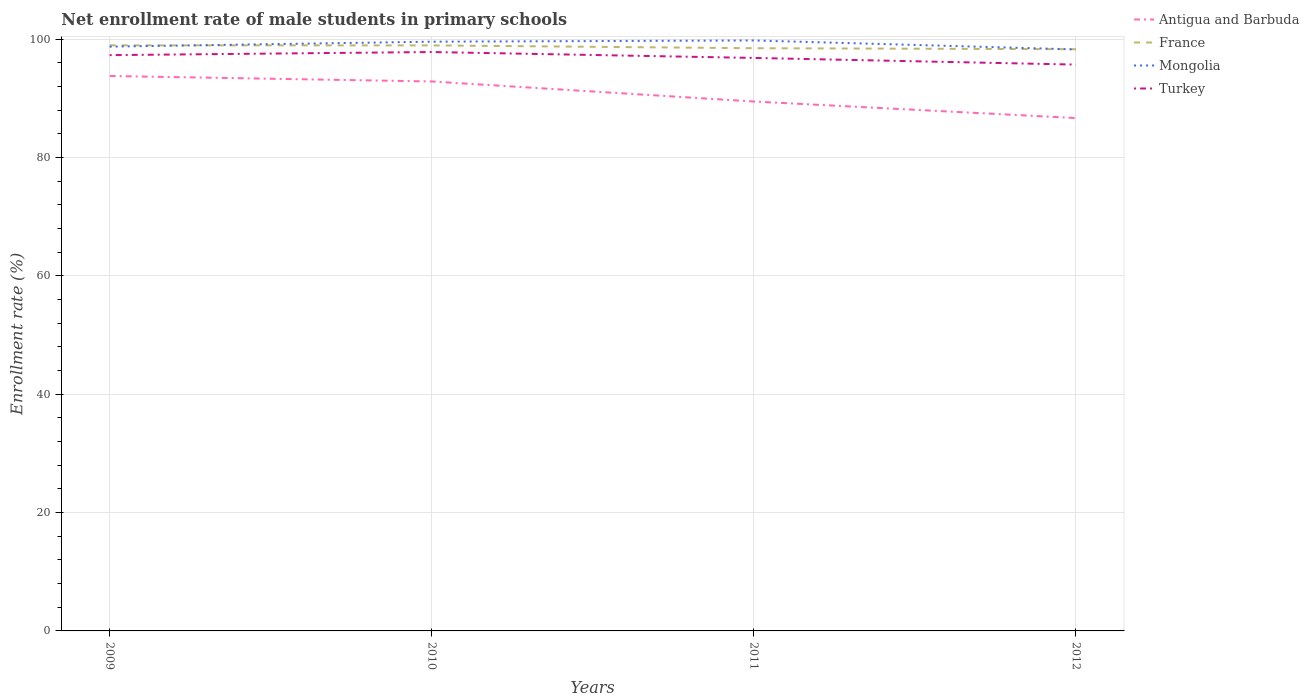How many different coloured lines are there?
Offer a very short reply. 4. Is the number of lines equal to the number of legend labels?
Give a very brief answer. Yes. Across all years, what is the maximum net enrollment rate of male students in primary schools in Mongolia?
Offer a terse response. 98.28. What is the total net enrollment rate of male students in primary schools in France in the graph?
Keep it short and to the point. 0.64. What is the difference between the highest and the second highest net enrollment rate of male students in primary schools in Antigua and Barbuda?
Give a very brief answer. 7.11. What is the difference between the highest and the lowest net enrollment rate of male students in primary schools in Mongolia?
Offer a terse response. 2. Is the net enrollment rate of male students in primary schools in Antigua and Barbuda strictly greater than the net enrollment rate of male students in primary schools in France over the years?
Your response must be concise. Yes. How many lines are there?
Your answer should be very brief. 4. How many years are there in the graph?
Give a very brief answer. 4. Does the graph contain grids?
Your answer should be very brief. Yes. Where does the legend appear in the graph?
Ensure brevity in your answer.  Top right. How are the legend labels stacked?
Offer a terse response. Vertical. What is the title of the graph?
Provide a short and direct response. Net enrollment rate of male students in primary schools. Does "Curacao" appear as one of the legend labels in the graph?
Your answer should be very brief. No. What is the label or title of the X-axis?
Your answer should be compact. Years. What is the label or title of the Y-axis?
Give a very brief answer. Enrollment rate (%). What is the Enrollment rate (%) in Antigua and Barbuda in 2009?
Give a very brief answer. 93.79. What is the Enrollment rate (%) in France in 2009?
Ensure brevity in your answer.  98.97. What is the Enrollment rate (%) of Mongolia in 2009?
Keep it short and to the point. 98.75. What is the Enrollment rate (%) in Turkey in 2009?
Give a very brief answer. 97.31. What is the Enrollment rate (%) of Antigua and Barbuda in 2010?
Offer a very short reply. 92.86. What is the Enrollment rate (%) of France in 2010?
Your answer should be compact. 98.96. What is the Enrollment rate (%) in Mongolia in 2010?
Your response must be concise. 99.59. What is the Enrollment rate (%) of Turkey in 2010?
Provide a short and direct response. 97.84. What is the Enrollment rate (%) in Antigua and Barbuda in 2011?
Offer a very short reply. 89.48. What is the Enrollment rate (%) in France in 2011?
Provide a short and direct response. 98.48. What is the Enrollment rate (%) in Mongolia in 2011?
Keep it short and to the point. 99.79. What is the Enrollment rate (%) in Turkey in 2011?
Offer a terse response. 96.84. What is the Enrollment rate (%) in Antigua and Barbuda in 2012?
Your response must be concise. 86.68. What is the Enrollment rate (%) in France in 2012?
Offer a terse response. 98.31. What is the Enrollment rate (%) in Mongolia in 2012?
Your response must be concise. 98.28. What is the Enrollment rate (%) in Turkey in 2012?
Your response must be concise. 95.71. Across all years, what is the maximum Enrollment rate (%) in Antigua and Barbuda?
Ensure brevity in your answer.  93.79. Across all years, what is the maximum Enrollment rate (%) in France?
Provide a succinct answer. 98.97. Across all years, what is the maximum Enrollment rate (%) in Mongolia?
Your answer should be compact. 99.79. Across all years, what is the maximum Enrollment rate (%) of Turkey?
Keep it short and to the point. 97.84. Across all years, what is the minimum Enrollment rate (%) of Antigua and Barbuda?
Your answer should be very brief. 86.68. Across all years, what is the minimum Enrollment rate (%) in France?
Offer a terse response. 98.31. Across all years, what is the minimum Enrollment rate (%) in Mongolia?
Your response must be concise. 98.28. Across all years, what is the minimum Enrollment rate (%) of Turkey?
Give a very brief answer. 95.71. What is the total Enrollment rate (%) in Antigua and Barbuda in the graph?
Provide a short and direct response. 362.81. What is the total Enrollment rate (%) in France in the graph?
Offer a very short reply. 394.72. What is the total Enrollment rate (%) in Mongolia in the graph?
Provide a short and direct response. 396.41. What is the total Enrollment rate (%) of Turkey in the graph?
Your answer should be compact. 387.71. What is the difference between the Enrollment rate (%) of Antigua and Barbuda in 2009 and that in 2010?
Provide a succinct answer. 0.92. What is the difference between the Enrollment rate (%) in France in 2009 and that in 2010?
Make the answer very short. 0.01. What is the difference between the Enrollment rate (%) of Mongolia in 2009 and that in 2010?
Ensure brevity in your answer.  -0.84. What is the difference between the Enrollment rate (%) of Turkey in 2009 and that in 2010?
Your response must be concise. -0.53. What is the difference between the Enrollment rate (%) of Antigua and Barbuda in 2009 and that in 2011?
Give a very brief answer. 4.31. What is the difference between the Enrollment rate (%) of France in 2009 and that in 2011?
Ensure brevity in your answer.  0.48. What is the difference between the Enrollment rate (%) in Mongolia in 2009 and that in 2011?
Provide a short and direct response. -1.04. What is the difference between the Enrollment rate (%) in Turkey in 2009 and that in 2011?
Your answer should be very brief. 0.47. What is the difference between the Enrollment rate (%) in Antigua and Barbuda in 2009 and that in 2012?
Your response must be concise. 7.11. What is the difference between the Enrollment rate (%) in France in 2009 and that in 2012?
Make the answer very short. 0.65. What is the difference between the Enrollment rate (%) in Mongolia in 2009 and that in 2012?
Your response must be concise. 0.47. What is the difference between the Enrollment rate (%) in Turkey in 2009 and that in 2012?
Ensure brevity in your answer.  1.6. What is the difference between the Enrollment rate (%) in Antigua and Barbuda in 2010 and that in 2011?
Your answer should be very brief. 3.39. What is the difference between the Enrollment rate (%) of France in 2010 and that in 2011?
Your response must be concise. 0.47. What is the difference between the Enrollment rate (%) in Mongolia in 2010 and that in 2011?
Offer a very short reply. -0.21. What is the difference between the Enrollment rate (%) in Turkey in 2010 and that in 2011?
Offer a very short reply. 1. What is the difference between the Enrollment rate (%) of Antigua and Barbuda in 2010 and that in 2012?
Provide a short and direct response. 6.18. What is the difference between the Enrollment rate (%) in France in 2010 and that in 2012?
Ensure brevity in your answer.  0.64. What is the difference between the Enrollment rate (%) of Mongolia in 2010 and that in 2012?
Keep it short and to the point. 1.31. What is the difference between the Enrollment rate (%) in Turkey in 2010 and that in 2012?
Offer a terse response. 2.12. What is the difference between the Enrollment rate (%) in Antigua and Barbuda in 2011 and that in 2012?
Offer a terse response. 2.8. What is the difference between the Enrollment rate (%) of France in 2011 and that in 2012?
Provide a succinct answer. 0.17. What is the difference between the Enrollment rate (%) in Mongolia in 2011 and that in 2012?
Give a very brief answer. 1.51. What is the difference between the Enrollment rate (%) in Turkey in 2011 and that in 2012?
Provide a short and direct response. 1.13. What is the difference between the Enrollment rate (%) in Antigua and Barbuda in 2009 and the Enrollment rate (%) in France in 2010?
Offer a very short reply. -5.17. What is the difference between the Enrollment rate (%) in Antigua and Barbuda in 2009 and the Enrollment rate (%) in Mongolia in 2010?
Provide a short and direct response. -5.8. What is the difference between the Enrollment rate (%) in Antigua and Barbuda in 2009 and the Enrollment rate (%) in Turkey in 2010?
Your answer should be compact. -4.05. What is the difference between the Enrollment rate (%) in France in 2009 and the Enrollment rate (%) in Mongolia in 2010?
Provide a succinct answer. -0.62. What is the difference between the Enrollment rate (%) of France in 2009 and the Enrollment rate (%) of Turkey in 2010?
Your answer should be very brief. 1.13. What is the difference between the Enrollment rate (%) of Mongolia in 2009 and the Enrollment rate (%) of Turkey in 2010?
Your answer should be very brief. 0.91. What is the difference between the Enrollment rate (%) in Antigua and Barbuda in 2009 and the Enrollment rate (%) in France in 2011?
Your answer should be compact. -4.7. What is the difference between the Enrollment rate (%) in Antigua and Barbuda in 2009 and the Enrollment rate (%) in Mongolia in 2011?
Keep it short and to the point. -6.01. What is the difference between the Enrollment rate (%) of Antigua and Barbuda in 2009 and the Enrollment rate (%) of Turkey in 2011?
Offer a very short reply. -3.05. What is the difference between the Enrollment rate (%) in France in 2009 and the Enrollment rate (%) in Mongolia in 2011?
Keep it short and to the point. -0.83. What is the difference between the Enrollment rate (%) of France in 2009 and the Enrollment rate (%) of Turkey in 2011?
Your response must be concise. 2.13. What is the difference between the Enrollment rate (%) of Mongolia in 2009 and the Enrollment rate (%) of Turkey in 2011?
Provide a succinct answer. 1.91. What is the difference between the Enrollment rate (%) in Antigua and Barbuda in 2009 and the Enrollment rate (%) in France in 2012?
Make the answer very short. -4.53. What is the difference between the Enrollment rate (%) of Antigua and Barbuda in 2009 and the Enrollment rate (%) of Mongolia in 2012?
Offer a terse response. -4.49. What is the difference between the Enrollment rate (%) in Antigua and Barbuda in 2009 and the Enrollment rate (%) in Turkey in 2012?
Ensure brevity in your answer.  -1.93. What is the difference between the Enrollment rate (%) of France in 2009 and the Enrollment rate (%) of Mongolia in 2012?
Offer a terse response. 0.69. What is the difference between the Enrollment rate (%) in France in 2009 and the Enrollment rate (%) in Turkey in 2012?
Offer a very short reply. 3.25. What is the difference between the Enrollment rate (%) in Mongolia in 2009 and the Enrollment rate (%) in Turkey in 2012?
Your answer should be compact. 3.04. What is the difference between the Enrollment rate (%) of Antigua and Barbuda in 2010 and the Enrollment rate (%) of France in 2011?
Ensure brevity in your answer.  -5.62. What is the difference between the Enrollment rate (%) in Antigua and Barbuda in 2010 and the Enrollment rate (%) in Mongolia in 2011?
Offer a terse response. -6.93. What is the difference between the Enrollment rate (%) of Antigua and Barbuda in 2010 and the Enrollment rate (%) of Turkey in 2011?
Ensure brevity in your answer.  -3.98. What is the difference between the Enrollment rate (%) in France in 2010 and the Enrollment rate (%) in Mongolia in 2011?
Offer a very short reply. -0.84. What is the difference between the Enrollment rate (%) of France in 2010 and the Enrollment rate (%) of Turkey in 2011?
Keep it short and to the point. 2.12. What is the difference between the Enrollment rate (%) in Mongolia in 2010 and the Enrollment rate (%) in Turkey in 2011?
Your response must be concise. 2.75. What is the difference between the Enrollment rate (%) of Antigua and Barbuda in 2010 and the Enrollment rate (%) of France in 2012?
Provide a succinct answer. -5.45. What is the difference between the Enrollment rate (%) in Antigua and Barbuda in 2010 and the Enrollment rate (%) in Mongolia in 2012?
Ensure brevity in your answer.  -5.42. What is the difference between the Enrollment rate (%) in Antigua and Barbuda in 2010 and the Enrollment rate (%) in Turkey in 2012?
Provide a succinct answer. -2.85. What is the difference between the Enrollment rate (%) in France in 2010 and the Enrollment rate (%) in Mongolia in 2012?
Give a very brief answer. 0.68. What is the difference between the Enrollment rate (%) in France in 2010 and the Enrollment rate (%) in Turkey in 2012?
Offer a terse response. 3.24. What is the difference between the Enrollment rate (%) in Mongolia in 2010 and the Enrollment rate (%) in Turkey in 2012?
Your answer should be compact. 3.87. What is the difference between the Enrollment rate (%) of Antigua and Barbuda in 2011 and the Enrollment rate (%) of France in 2012?
Give a very brief answer. -8.84. What is the difference between the Enrollment rate (%) of Antigua and Barbuda in 2011 and the Enrollment rate (%) of Mongolia in 2012?
Your answer should be compact. -8.8. What is the difference between the Enrollment rate (%) of Antigua and Barbuda in 2011 and the Enrollment rate (%) of Turkey in 2012?
Offer a terse response. -6.24. What is the difference between the Enrollment rate (%) of France in 2011 and the Enrollment rate (%) of Mongolia in 2012?
Make the answer very short. 0.2. What is the difference between the Enrollment rate (%) in France in 2011 and the Enrollment rate (%) in Turkey in 2012?
Provide a short and direct response. 2.77. What is the difference between the Enrollment rate (%) in Mongolia in 2011 and the Enrollment rate (%) in Turkey in 2012?
Offer a terse response. 4.08. What is the average Enrollment rate (%) in Antigua and Barbuda per year?
Offer a very short reply. 90.7. What is the average Enrollment rate (%) of France per year?
Provide a succinct answer. 98.68. What is the average Enrollment rate (%) of Mongolia per year?
Give a very brief answer. 99.1. What is the average Enrollment rate (%) in Turkey per year?
Your response must be concise. 96.93. In the year 2009, what is the difference between the Enrollment rate (%) in Antigua and Barbuda and Enrollment rate (%) in France?
Your answer should be very brief. -5.18. In the year 2009, what is the difference between the Enrollment rate (%) in Antigua and Barbuda and Enrollment rate (%) in Mongolia?
Offer a terse response. -4.96. In the year 2009, what is the difference between the Enrollment rate (%) of Antigua and Barbuda and Enrollment rate (%) of Turkey?
Offer a very short reply. -3.53. In the year 2009, what is the difference between the Enrollment rate (%) in France and Enrollment rate (%) in Mongolia?
Keep it short and to the point. 0.22. In the year 2009, what is the difference between the Enrollment rate (%) of France and Enrollment rate (%) of Turkey?
Ensure brevity in your answer.  1.65. In the year 2009, what is the difference between the Enrollment rate (%) of Mongolia and Enrollment rate (%) of Turkey?
Offer a very short reply. 1.44. In the year 2010, what is the difference between the Enrollment rate (%) of Antigua and Barbuda and Enrollment rate (%) of France?
Your answer should be very brief. -6.09. In the year 2010, what is the difference between the Enrollment rate (%) in Antigua and Barbuda and Enrollment rate (%) in Mongolia?
Your answer should be compact. -6.72. In the year 2010, what is the difference between the Enrollment rate (%) of Antigua and Barbuda and Enrollment rate (%) of Turkey?
Your answer should be very brief. -4.97. In the year 2010, what is the difference between the Enrollment rate (%) in France and Enrollment rate (%) in Mongolia?
Your answer should be compact. -0.63. In the year 2010, what is the difference between the Enrollment rate (%) of France and Enrollment rate (%) of Turkey?
Provide a succinct answer. 1.12. In the year 2010, what is the difference between the Enrollment rate (%) of Mongolia and Enrollment rate (%) of Turkey?
Your answer should be compact. 1.75. In the year 2011, what is the difference between the Enrollment rate (%) of Antigua and Barbuda and Enrollment rate (%) of France?
Make the answer very short. -9.01. In the year 2011, what is the difference between the Enrollment rate (%) of Antigua and Barbuda and Enrollment rate (%) of Mongolia?
Give a very brief answer. -10.32. In the year 2011, what is the difference between the Enrollment rate (%) in Antigua and Barbuda and Enrollment rate (%) in Turkey?
Ensure brevity in your answer.  -7.36. In the year 2011, what is the difference between the Enrollment rate (%) of France and Enrollment rate (%) of Mongolia?
Keep it short and to the point. -1.31. In the year 2011, what is the difference between the Enrollment rate (%) in France and Enrollment rate (%) in Turkey?
Provide a succinct answer. 1.64. In the year 2011, what is the difference between the Enrollment rate (%) of Mongolia and Enrollment rate (%) of Turkey?
Offer a very short reply. 2.95. In the year 2012, what is the difference between the Enrollment rate (%) of Antigua and Barbuda and Enrollment rate (%) of France?
Provide a short and direct response. -11.63. In the year 2012, what is the difference between the Enrollment rate (%) of Antigua and Barbuda and Enrollment rate (%) of Mongolia?
Keep it short and to the point. -11.6. In the year 2012, what is the difference between the Enrollment rate (%) of Antigua and Barbuda and Enrollment rate (%) of Turkey?
Provide a short and direct response. -9.04. In the year 2012, what is the difference between the Enrollment rate (%) of France and Enrollment rate (%) of Mongolia?
Offer a terse response. 0.03. In the year 2012, what is the difference between the Enrollment rate (%) of France and Enrollment rate (%) of Turkey?
Offer a very short reply. 2.6. In the year 2012, what is the difference between the Enrollment rate (%) of Mongolia and Enrollment rate (%) of Turkey?
Make the answer very short. 2.57. What is the ratio of the Enrollment rate (%) of France in 2009 to that in 2010?
Your answer should be very brief. 1. What is the ratio of the Enrollment rate (%) in Mongolia in 2009 to that in 2010?
Your answer should be compact. 0.99. What is the ratio of the Enrollment rate (%) of Turkey in 2009 to that in 2010?
Ensure brevity in your answer.  0.99. What is the ratio of the Enrollment rate (%) of Antigua and Barbuda in 2009 to that in 2011?
Offer a very short reply. 1.05. What is the ratio of the Enrollment rate (%) of Antigua and Barbuda in 2009 to that in 2012?
Make the answer very short. 1.08. What is the ratio of the Enrollment rate (%) in France in 2009 to that in 2012?
Offer a very short reply. 1.01. What is the ratio of the Enrollment rate (%) in Turkey in 2009 to that in 2012?
Keep it short and to the point. 1.02. What is the ratio of the Enrollment rate (%) of Antigua and Barbuda in 2010 to that in 2011?
Ensure brevity in your answer.  1.04. What is the ratio of the Enrollment rate (%) in France in 2010 to that in 2011?
Provide a short and direct response. 1. What is the ratio of the Enrollment rate (%) in Turkey in 2010 to that in 2011?
Provide a short and direct response. 1.01. What is the ratio of the Enrollment rate (%) of Antigua and Barbuda in 2010 to that in 2012?
Offer a very short reply. 1.07. What is the ratio of the Enrollment rate (%) in France in 2010 to that in 2012?
Offer a terse response. 1.01. What is the ratio of the Enrollment rate (%) of Mongolia in 2010 to that in 2012?
Your answer should be compact. 1.01. What is the ratio of the Enrollment rate (%) of Turkey in 2010 to that in 2012?
Ensure brevity in your answer.  1.02. What is the ratio of the Enrollment rate (%) in Antigua and Barbuda in 2011 to that in 2012?
Give a very brief answer. 1.03. What is the ratio of the Enrollment rate (%) of France in 2011 to that in 2012?
Your answer should be compact. 1. What is the ratio of the Enrollment rate (%) in Mongolia in 2011 to that in 2012?
Give a very brief answer. 1.02. What is the ratio of the Enrollment rate (%) in Turkey in 2011 to that in 2012?
Offer a very short reply. 1.01. What is the difference between the highest and the second highest Enrollment rate (%) in Antigua and Barbuda?
Your answer should be compact. 0.92. What is the difference between the highest and the second highest Enrollment rate (%) in France?
Your answer should be compact. 0.01. What is the difference between the highest and the second highest Enrollment rate (%) in Mongolia?
Your answer should be very brief. 0.21. What is the difference between the highest and the second highest Enrollment rate (%) in Turkey?
Your answer should be very brief. 0.53. What is the difference between the highest and the lowest Enrollment rate (%) in Antigua and Barbuda?
Ensure brevity in your answer.  7.11. What is the difference between the highest and the lowest Enrollment rate (%) in France?
Make the answer very short. 0.65. What is the difference between the highest and the lowest Enrollment rate (%) of Mongolia?
Make the answer very short. 1.51. What is the difference between the highest and the lowest Enrollment rate (%) of Turkey?
Ensure brevity in your answer.  2.12. 